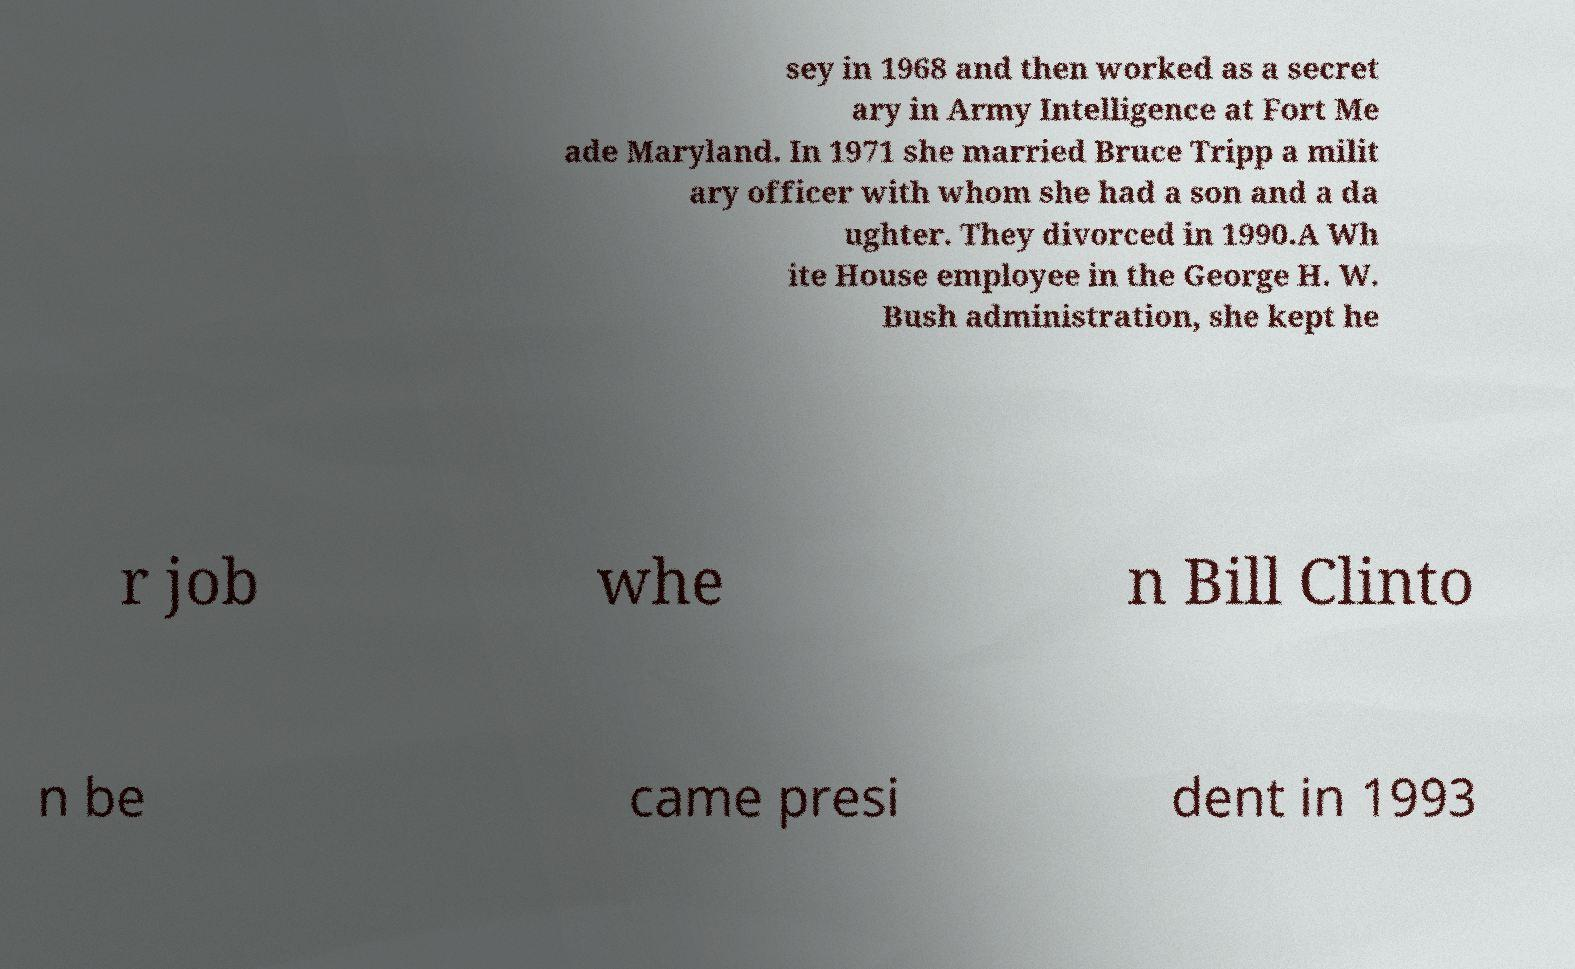Please identify and transcribe the text found in this image. sey in 1968 and then worked as a secret ary in Army Intelligence at Fort Me ade Maryland. In 1971 she married Bruce Tripp a milit ary officer with whom she had a son and a da ughter. They divorced in 1990.A Wh ite House employee in the George H. W. Bush administration, she kept he r job whe n Bill Clinto n be came presi dent in 1993 